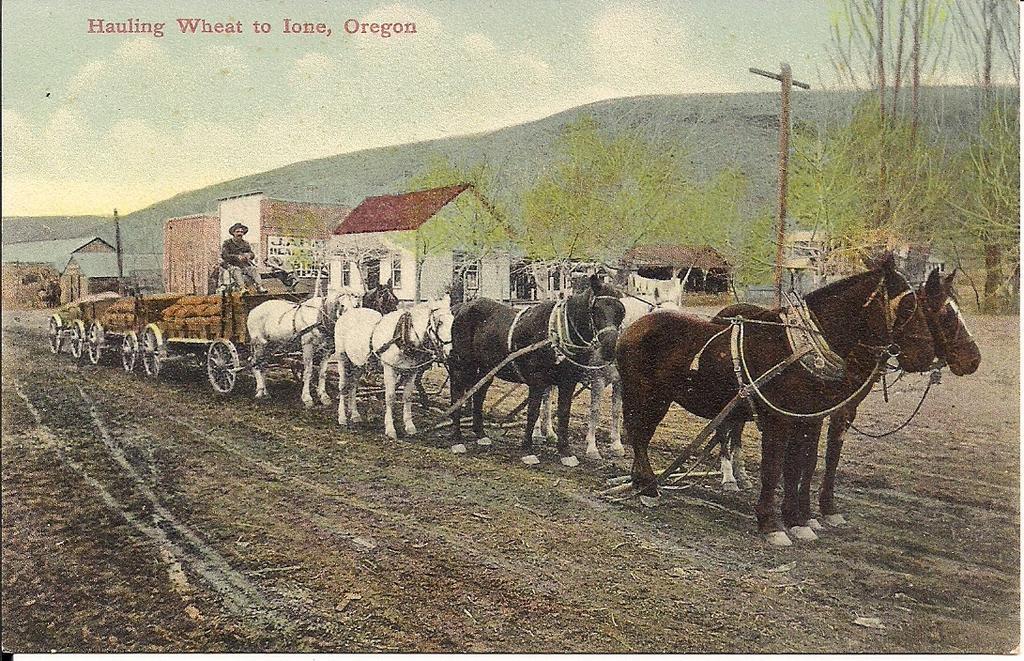Please provide a concise description of this image. In this image, we can see a poster with some text and images. 